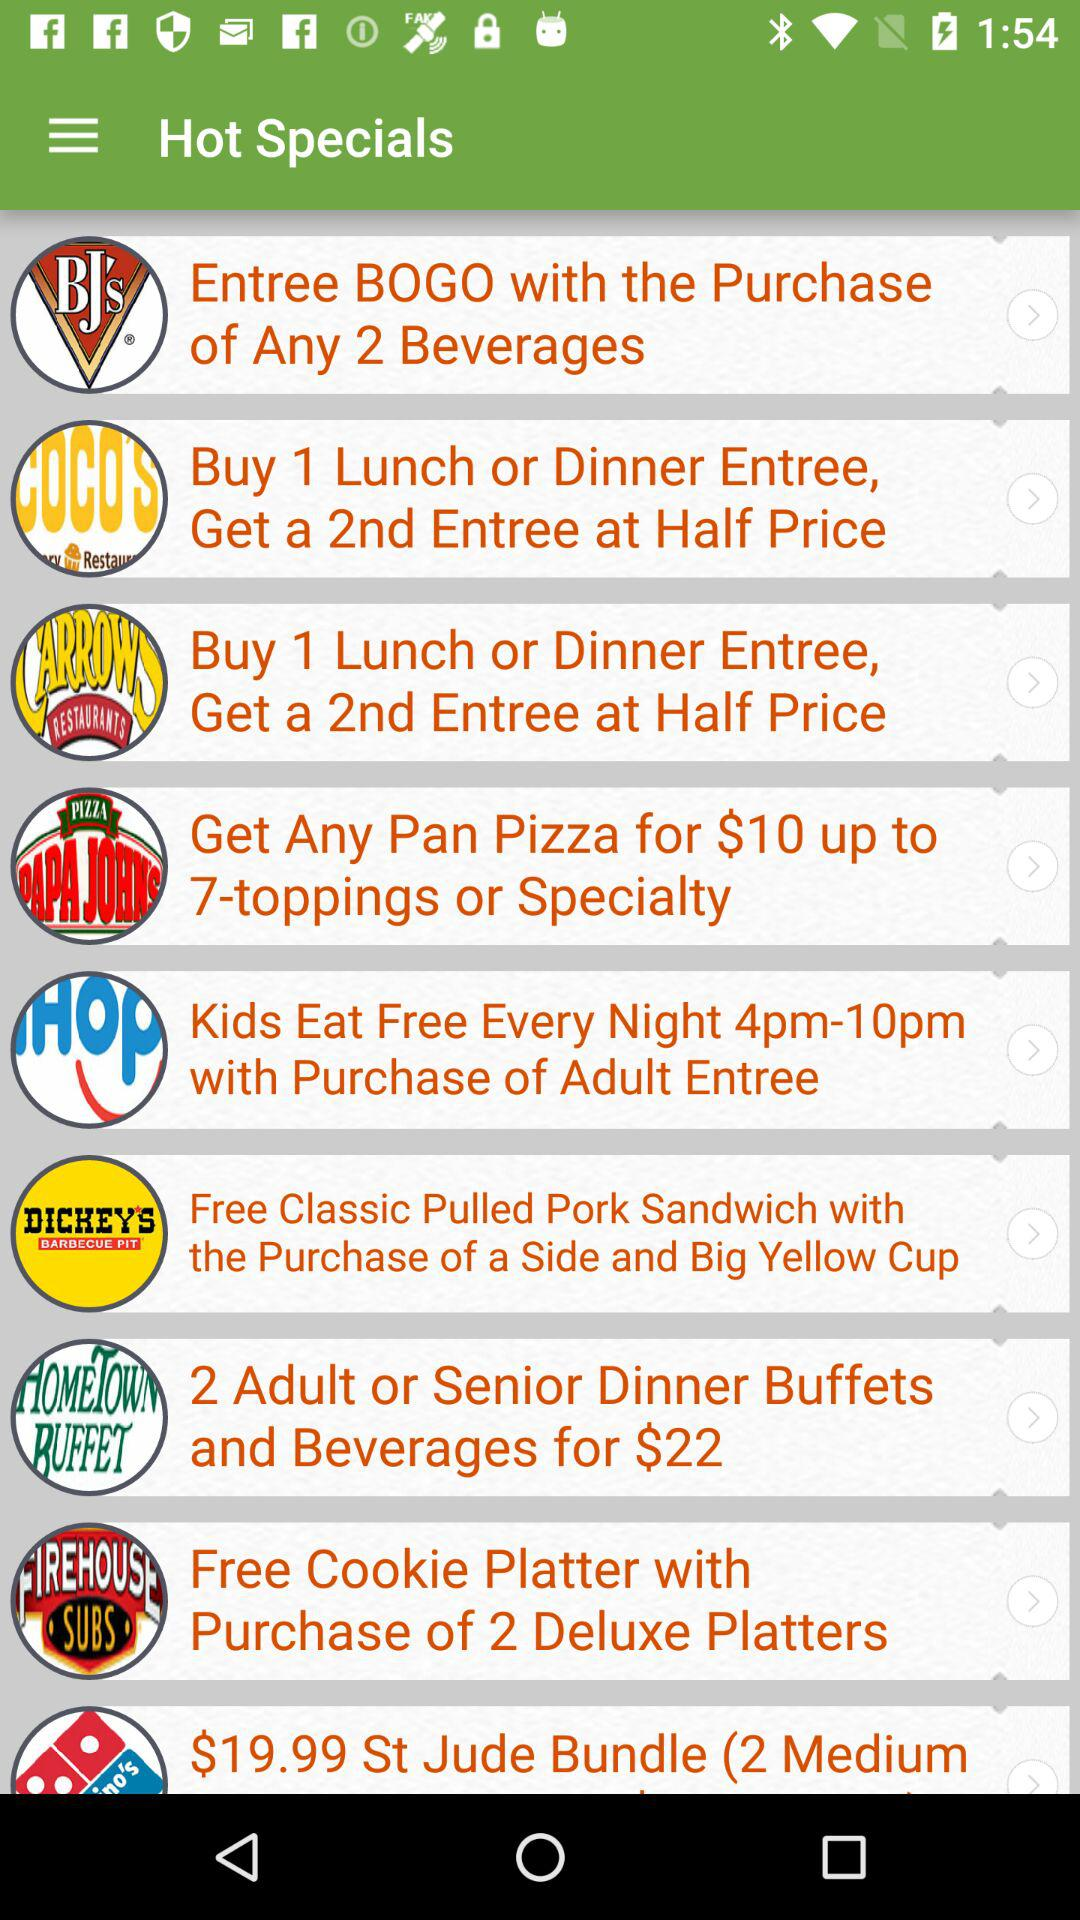What is the price of any pan pizza with 7 toppings or a specialty? The price is $10. 